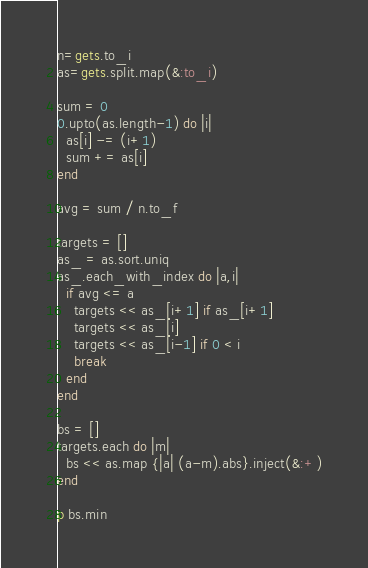<code> <loc_0><loc_0><loc_500><loc_500><_Ruby_>n=gets.to_i
as=gets.split.map(&:to_i)

sum = 0
0.upto(as.length-1) do |i|
  as[i] -= (i+1)
  sum += as[i]
end

avg = sum / n.to_f

targets = []
as_ = as.sort.uniq
as_.each_with_index do |a,i|
  if avg <= a
    targets << as_[i+1] if as_[i+1]
    targets << as_[i]
    targets << as_[i-1] if 0 < i
    break
  end
end

bs = []
targets.each do |m|
  bs << as.map {|a| (a-m).abs}.inject(&:+)
end

p bs.min</code> 